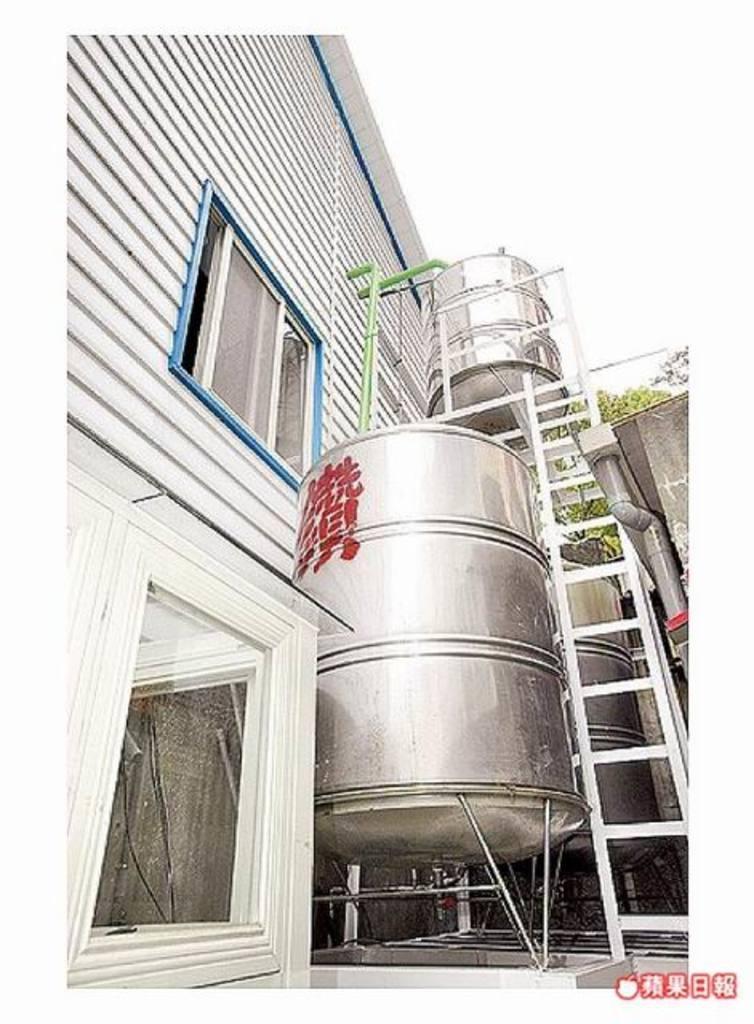Describe this image in one or two sentences. In this picture I can see water barrels near to the wooden wall and window. On the left there is a building. On the right I can see the ladder, beside that I can see the pipe. In the background I can see the trees. In the top right there is a sky. In the bottom right corner there is a watermark. 